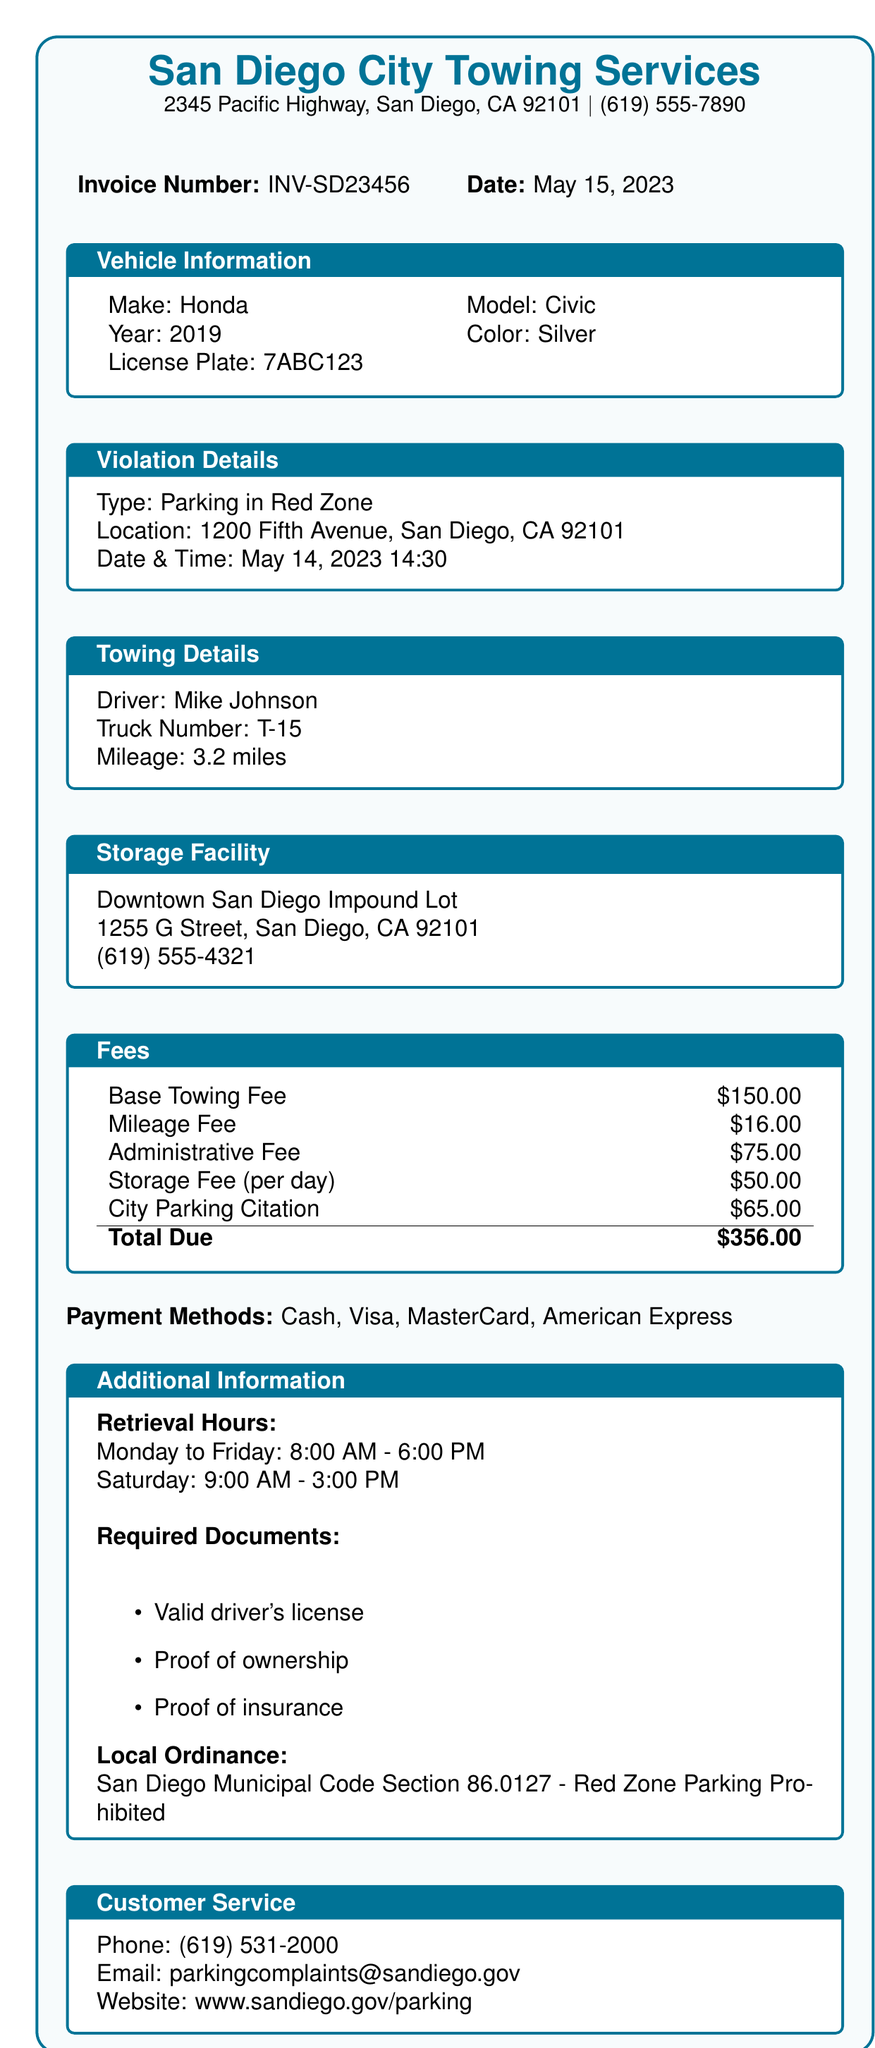What is the name of the towing company? The name of the towing company is printed at the top of the document.
Answer: San Diego City Towing Services What is the invoice number? The invoice number is clearly stated in the document, identifying this specific bill.
Answer: INV-SD23456 What date was the vehicle towed? The date of the violation and towing is indicated in the violation details section.
Answer: May 14, 2023 Who was the driver of the towing truck? The driver's name is provided in the towing details section of the document.
Answer: Mike Johnson What is the total fee due? The total fee is computed from the listed fees and is highlighted at the bottom of the fees section.
Answer: $356.00 What is the location of the impound lot? The location of the storage facility is listed under the storage facility section of the document.
Answer: 1255 G Street, San Diego, CA 92101 What is one required document to retrieve the vehicle? The document lists specific required documents for vehicle retrieval, providing multiple options.
Answer: Valid driver's license What are the retrieval hours on Saturday? The hours for retrieving the vehicle are specified in the additional information section for each day of the week.
Answer: 9:00 AM - 3:00 PM Which section of the municipal code relates to this violation? The local ordinance section provides specific regulatory details relating to parking violations.
Answer: San Diego Municipal Code Section 86.0127 - Red Zone Parking Prohibited 